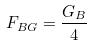Convert formula to latex. <formula><loc_0><loc_0><loc_500><loc_500>F _ { B G } = \frac { G _ { B } } { 4 }</formula> 